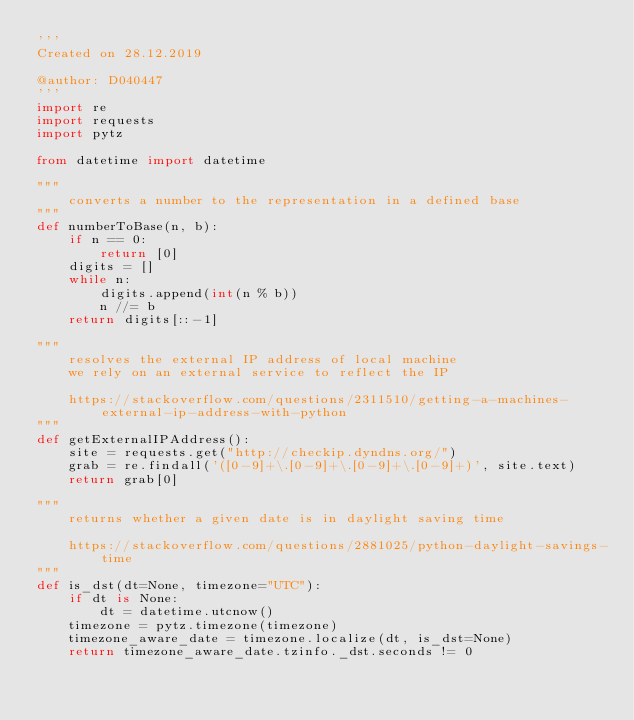Convert code to text. <code><loc_0><loc_0><loc_500><loc_500><_Python_>'''
Created on 28.12.2019

@author: D040447
'''
import re
import requests
import pytz

from datetime import datetime

"""
    converts a number to the representation in a defined base
""" 
def numberToBase(n, b):
    if n == 0:
        return [0]
    digits = []
    while n:
        digits.append(int(n % b))
        n //= b
    return digits[::-1]

"""
    resolves the external IP address of local machine
    we rely on an external service to reflect the IP
    
    https://stackoverflow.com/questions/2311510/getting-a-machines-external-ip-address-with-python
"""
def getExternalIPAddress():
    site = requests.get("http://checkip.dyndns.org/")
    grab = re.findall('([0-9]+\.[0-9]+\.[0-9]+\.[0-9]+)', site.text)
    return grab[0]

"""
    returns whether a given date is in daylight saving time
    
    https://stackoverflow.com/questions/2881025/python-daylight-savings-time
"""
def is_dst(dt=None, timezone="UTC"):
    if dt is None:
        dt = datetime.utcnow()
    timezone = pytz.timezone(timezone)
    timezone_aware_date = timezone.localize(dt, is_dst=None)
    return timezone_aware_date.tzinfo._dst.seconds != 0</code> 